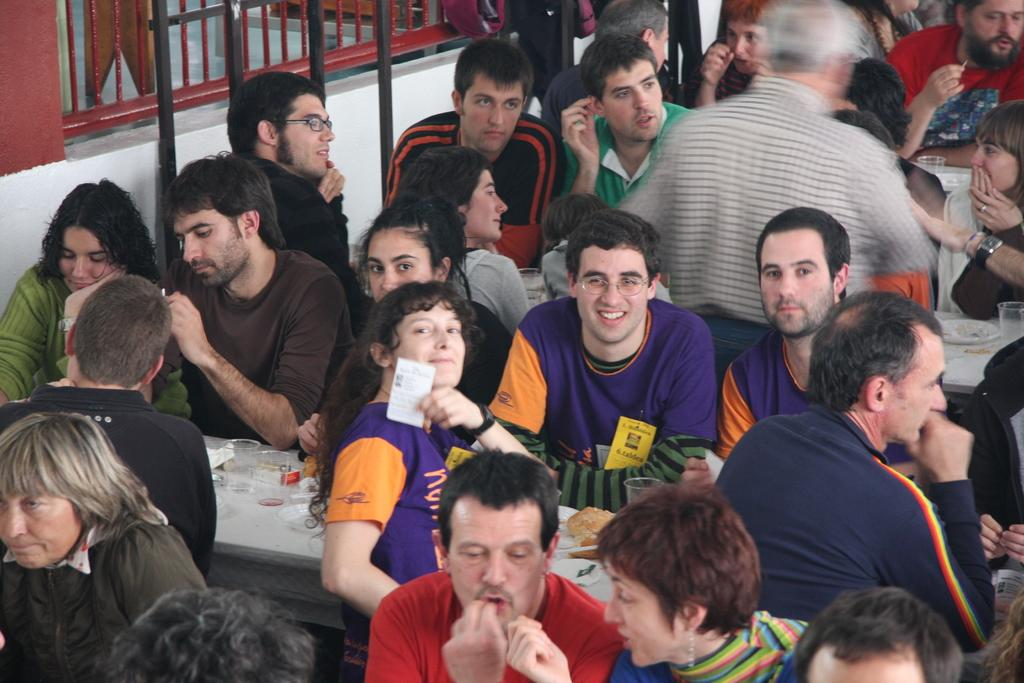What are the people in the image doing? The people in the image are sitting. What objects are present on the tables in the image? Glasses, food, and plates are present on the tables in the image. What can be seen in the background of the image? There is a railing and a wall in the background of the image. What type of cable is being used by the people in the image? There is no cable visible in the image; the people are sitting and there are tables with glasses, food, and plates. 